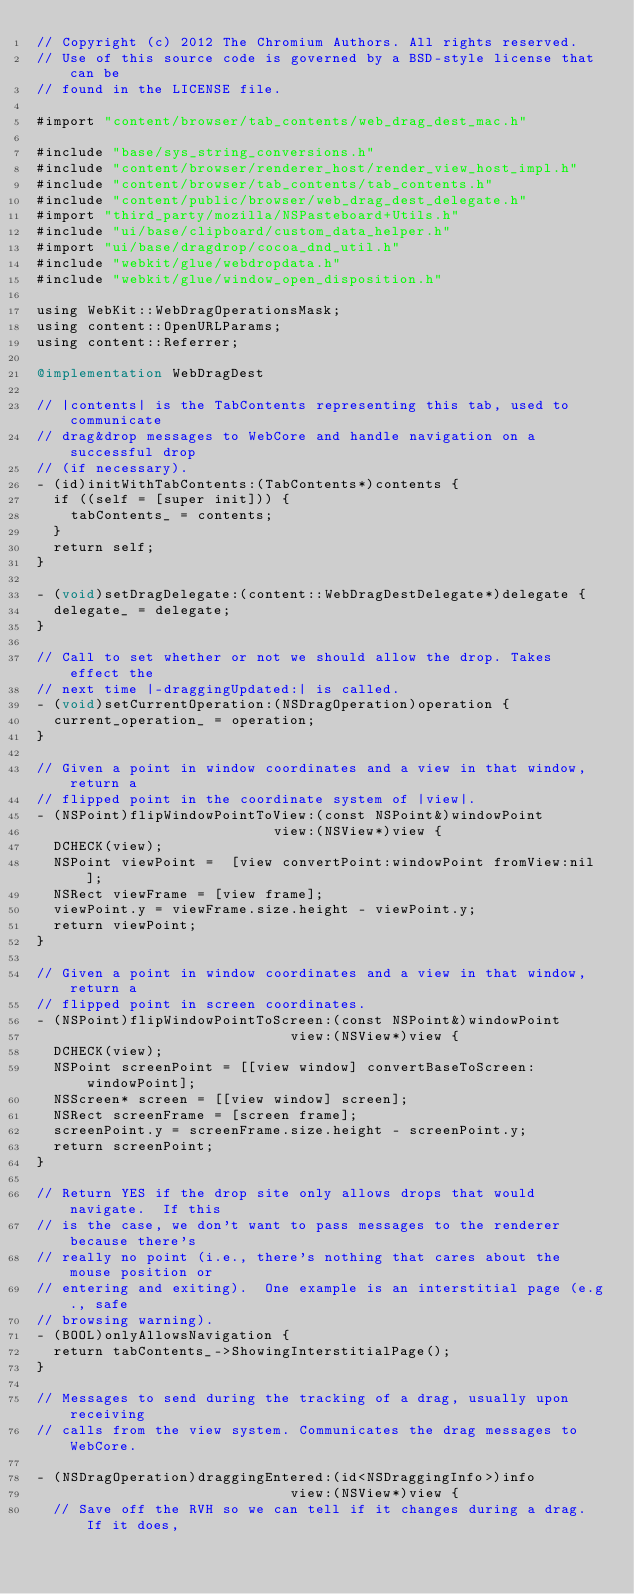<code> <loc_0><loc_0><loc_500><loc_500><_ObjectiveC_>// Copyright (c) 2012 The Chromium Authors. All rights reserved.
// Use of this source code is governed by a BSD-style license that can be
// found in the LICENSE file.

#import "content/browser/tab_contents/web_drag_dest_mac.h"

#include "base/sys_string_conversions.h"
#include "content/browser/renderer_host/render_view_host_impl.h"
#include "content/browser/tab_contents/tab_contents.h"
#include "content/public/browser/web_drag_dest_delegate.h"
#import "third_party/mozilla/NSPasteboard+Utils.h"
#include "ui/base/clipboard/custom_data_helper.h"
#import "ui/base/dragdrop/cocoa_dnd_util.h"
#include "webkit/glue/webdropdata.h"
#include "webkit/glue/window_open_disposition.h"

using WebKit::WebDragOperationsMask;
using content::OpenURLParams;
using content::Referrer;

@implementation WebDragDest

// |contents| is the TabContents representing this tab, used to communicate
// drag&drop messages to WebCore and handle navigation on a successful drop
// (if necessary).
- (id)initWithTabContents:(TabContents*)contents {
  if ((self = [super init])) {
    tabContents_ = contents;
  }
  return self;
}

- (void)setDragDelegate:(content::WebDragDestDelegate*)delegate {
  delegate_ = delegate;
}

// Call to set whether or not we should allow the drop. Takes effect the
// next time |-draggingUpdated:| is called.
- (void)setCurrentOperation:(NSDragOperation)operation {
  current_operation_ = operation;
}

// Given a point in window coordinates and a view in that window, return a
// flipped point in the coordinate system of |view|.
- (NSPoint)flipWindowPointToView:(const NSPoint&)windowPoint
                            view:(NSView*)view {
  DCHECK(view);
  NSPoint viewPoint =  [view convertPoint:windowPoint fromView:nil];
  NSRect viewFrame = [view frame];
  viewPoint.y = viewFrame.size.height - viewPoint.y;
  return viewPoint;
}

// Given a point in window coordinates and a view in that window, return a
// flipped point in screen coordinates.
- (NSPoint)flipWindowPointToScreen:(const NSPoint&)windowPoint
                              view:(NSView*)view {
  DCHECK(view);
  NSPoint screenPoint = [[view window] convertBaseToScreen:windowPoint];
  NSScreen* screen = [[view window] screen];
  NSRect screenFrame = [screen frame];
  screenPoint.y = screenFrame.size.height - screenPoint.y;
  return screenPoint;
}

// Return YES if the drop site only allows drops that would navigate.  If this
// is the case, we don't want to pass messages to the renderer because there's
// really no point (i.e., there's nothing that cares about the mouse position or
// entering and exiting).  One example is an interstitial page (e.g., safe
// browsing warning).
- (BOOL)onlyAllowsNavigation {
  return tabContents_->ShowingInterstitialPage();
}

// Messages to send during the tracking of a drag, usually upon receiving
// calls from the view system. Communicates the drag messages to WebCore.

- (NSDragOperation)draggingEntered:(id<NSDraggingInfo>)info
                              view:(NSView*)view {
  // Save off the RVH so we can tell if it changes during a drag. If it does,</code> 